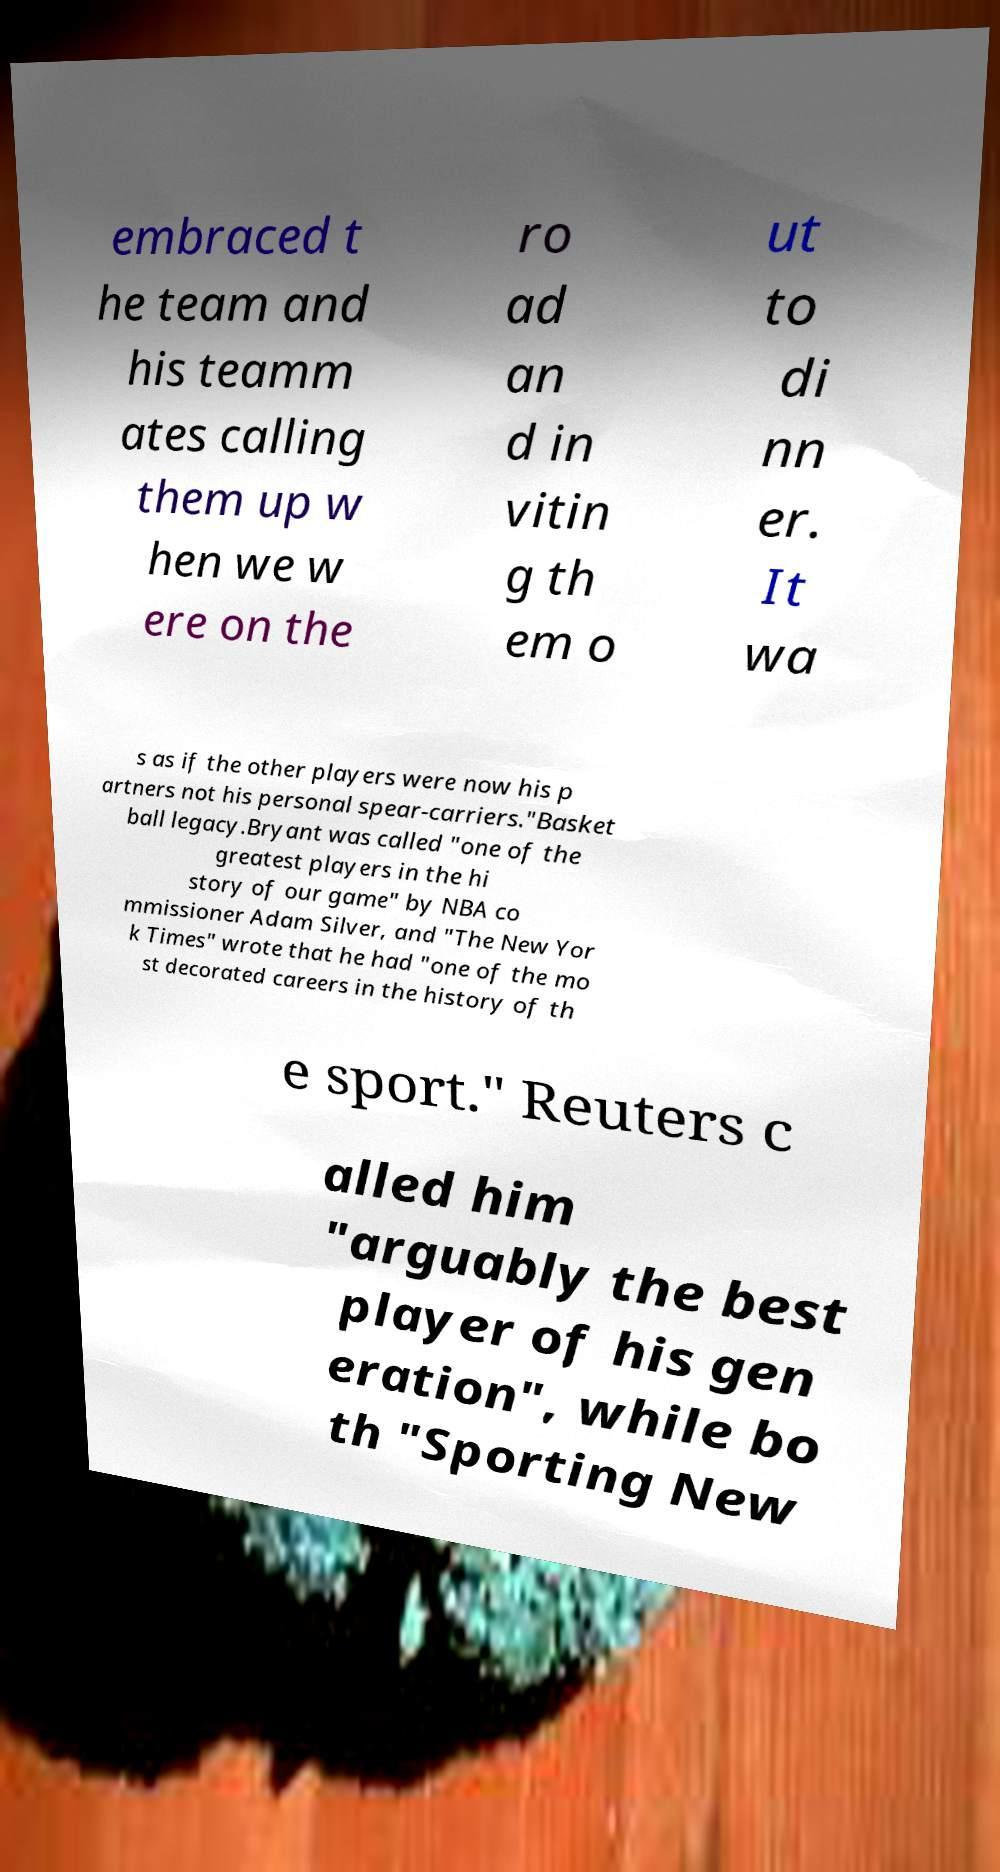Can you accurately transcribe the text from the provided image for me? embraced t he team and his teamm ates calling them up w hen we w ere on the ro ad an d in vitin g th em o ut to di nn er. It wa s as if the other players were now his p artners not his personal spear-carriers."Basket ball legacy.Bryant was called "one of the greatest players in the hi story of our game" by NBA co mmissioner Adam Silver, and "The New Yor k Times" wrote that he had "one of the mo st decorated careers in the history of th e sport." Reuters c alled him "arguably the best player of his gen eration", while bo th "Sporting New 